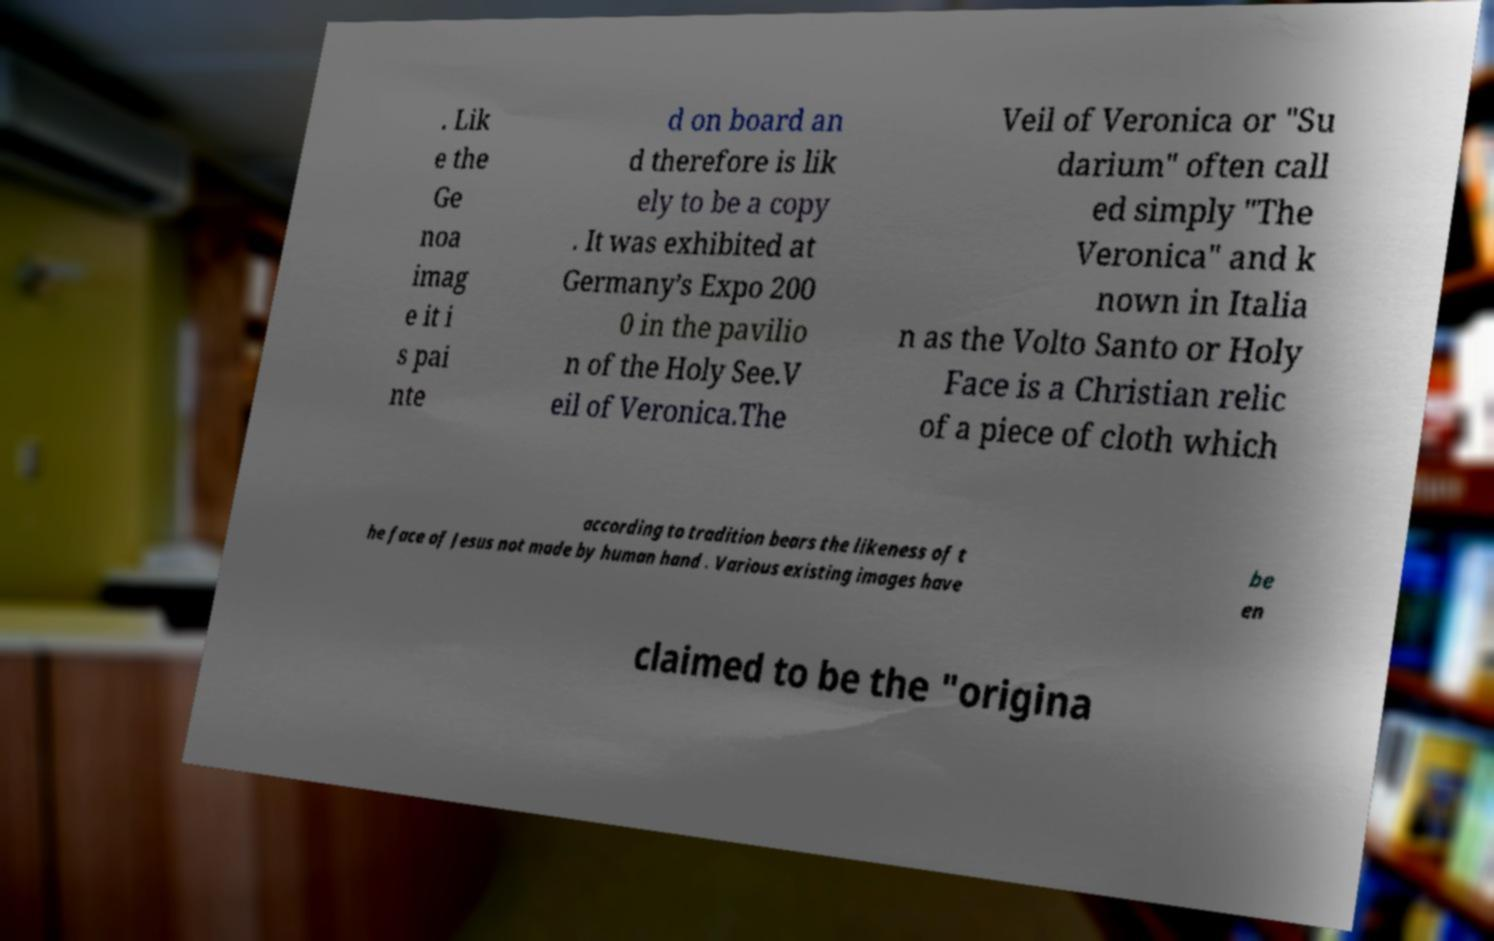What messages or text are displayed in this image? I need them in a readable, typed format. . Lik e the Ge noa imag e it i s pai nte d on board an d therefore is lik ely to be a copy . It was exhibited at Germany’s Expo 200 0 in the pavilio n of the Holy See.V eil of Veronica.The Veil of Veronica or "Su darium" often call ed simply "The Veronica" and k nown in Italia n as the Volto Santo or Holy Face is a Christian relic of a piece of cloth which according to tradition bears the likeness of t he face of Jesus not made by human hand . Various existing images have be en claimed to be the "origina 